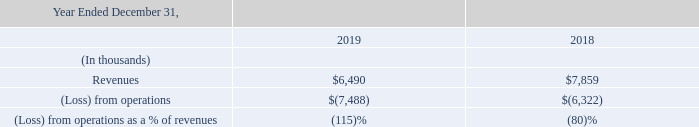Asia Pacific
Asia Pacific net revenues decreased $1.4 million in 2019 compared to 2018 (see “Revenues” above). Asia Pacific expenses decreased $203,000 from 2018 to 2019. This decrease was primarily due to a $503,000 decrease of salary expense, offset partially by a $303,000 increase in member acquisition costs.
Foreign currency movements relative to the U.S. dollar negatively impacted our local currency loss from our operations in Asia Pacific by approximately $136,000 for 2019. Foreign currency movements relative to the U.S. dollar positively impacted our local currency loss from our operations in Asia Pacific by approximately $127,000 for 2018.
What is the amount of revenues in 2019 and 2018 respectively?
Answer scale should be: thousand. $6,490, $7,859. What is the loss from operations in 2019 and 2018 respectively?
Answer scale should be: thousand. 7,488, 6,322. How much did Asia Pacific expenses decrease by from 2018 to 2019? $203,000. Which year has a higher amount of revenue? Look at COL3 and COL4 and compare the values for revenues in Row 4 
Answer: 2018. What is the average amount of revenues in 2018 and 2019?
Answer scale should be: thousand. (6,490+ 7,859)/2
Answer: 7174.5. What is the percentage change in revenue from 2018 to 2019?
Answer scale should be: percent. (6,490-7,859)/7,859
Answer: -17.42. 